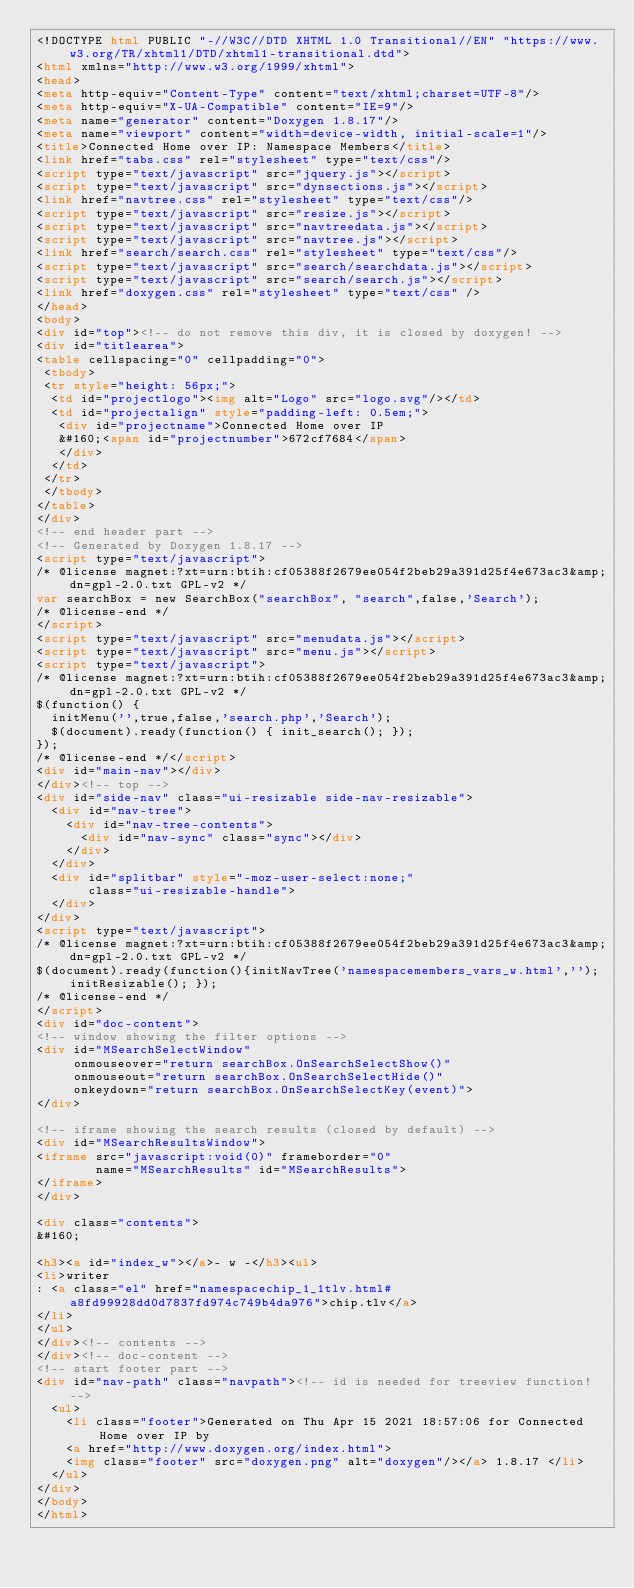Convert code to text. <code><loc_0><loc_0><loc_500><loc_500><_HTML_><!DOCTYPE html PUBLIC "-//W3C//DTD XHTML 1.0 Transitional//EN" "https://www.w3.org/TR/xhtml1/DTD/xhtml1-transitional.dtd">
<html xmlns="http://www.w3.org/1999/xhtml">
<head>
<meta http-equiv="Content-Type" content="text/xhtml;charset=UTF-8"/>
<meta http-equiv="X-UA-Compatible" content="IE=9"/>
<meta name="generator" content="Doxygen 1.8.17"/>
<meta name="viewport" content="width=device-width, initial-scale=1"/>
<title>Connected Home over IP: Namespace Members</title>
<link href="tabs.css" rel="stylesheet" type="text/css"/>
<script type="text/javascript" src="jquery.js"></script>
<script type="text/javascript" src="dynsections.js"></script>
<link href="navtree.css" rel="stylesheet" type="text/css"/>
<script type="text/javascript" src="resize.js"></script>
<script type="text/javascript" src="navtreedata.js"></script>
<script type="text/javascript" src="navtree.js"></script>
<link href="search/search.css" rel="stylesheet" type="text/css"/>
<script type="text/javascript" src="search/searchdata.js"></script>
<script type="text/javascript" src="search/search.js"></script>
<link href="doxygen.css" rel="stylesheet" type="text/css" />
</head>
<body>
<div id="top"><!-- do not remove this div, it is closed by doxygen! -->
<div id="titlearea">
<table cellspacing="0" cellpadding="0">
 <tbody>
 <tr style="height: 56px;">
  <td id="projectlogo"><img alt="Logo" src="logo.svg"/></td>
  <td id="projectalign" style="padding-left: 0.5em;">
   <div id="projectname">Connected Home over IP
   &#160;<span id="projectnumber">672cf7684</span>
   </div>
  </td>
 </tr>
 </tbody>
</table>
</div>
<!-- end header part -->
<!-- Generated by Doxygen 1.8.17 -->
<script type="text/javascript">
/* @license magnet:?xt=urn:btih:cf05388f2679ee054f2beb29a391d25f4e673ac3&amp;dn=gpl-2.0.txt GPL-v2 */
var searchBox = new SearchBox("searchBox", "search",false,'Search');
/* @license-end */
</script>
<script type="text/javascript" src="menudata.js"></script>
<script type="text/javascript" src="menu.js"></script>
<script type="text/javascript">
/* @license magnet:?xt=urn:btih:cf05388f2679ee054f2beb29a391d25f4e673ac3&amp;dn=gpl-2.0.txt GPL-v2 */
$(function() {
  initMenu('',true,false,'search.php','Search');
  $(document).ready(function() { init_search(); });
});
/* @license-end */</script>
<div id="main-nav"></div>
</div><!-- top -->
<div id="side-nav" class="ui-resizable side-nav-resizable">
  <div id="nav-tree">
    <div id="nav-tree-contents">
      <div id="nav-sync" class="sync"></div>
    </div>
  </div>
  <div id="splitbar" style="-moz-user-select:none;" 
       class="ui-resizable-handle">
  </div>
</div>
<script type="text/javascript">
/* @license magnet:?xt=urn:btih:cf05388f2679ee054f2beb29a391d25f4e673ac3&amp;dn=gpl-2.0.txt GPL-v2 */
$(document).ready(function(){initNavTree('namespacemembers_vars_w.html',''); initResizable(); });
/* @license-end */
</script>
<div id="doc-content">
<!-- window showing the filter options -->
<div id="MSearchSelectWindow"
     onmouseover="return searchBox.OnSearchSelectShow()"
     onmouseout="return searchBox.OnSearchSelectHide()"
     onkeydown="return searchBox.OnSearchSelectKey(event)">
</div>

<!-- iframe showing the search results (closed by default) -->
<div id="MSearchResultsWindow">
<iframe src="javascript:void(0)" frameborder="0" 
        name="MSearchResults" id="MSearchResults">
</iframe>
</div>

<div class="contents">
&#160;

<h3><a id="index_w"></a>- w -</h3><ul>
<li>writer
: <a class="el" href="namespacechip_1_1tlv.html#a8fd99928dd0d7837fd974c749b4da976">chip.tlv</a>
</li>
</ul>
</div><!-- contents -->
</div><!-- doc-content -->
<!-- start footer part -->
<div id="nav-path" class="navpath"><!-- id is needed for treeview function! -->
  <ul>
    <li class="footer">Generated on Thu Apr 15 2021 18:57:06 for Connected Home over IP by
    <a href="http://www.doxygen.org/index.html">
    <img class="footer" src="doxygen.png" alt="doxygen"/></a> 1.8.17 </li>
  </ul>
</div>
</body>
</html>
</code> 